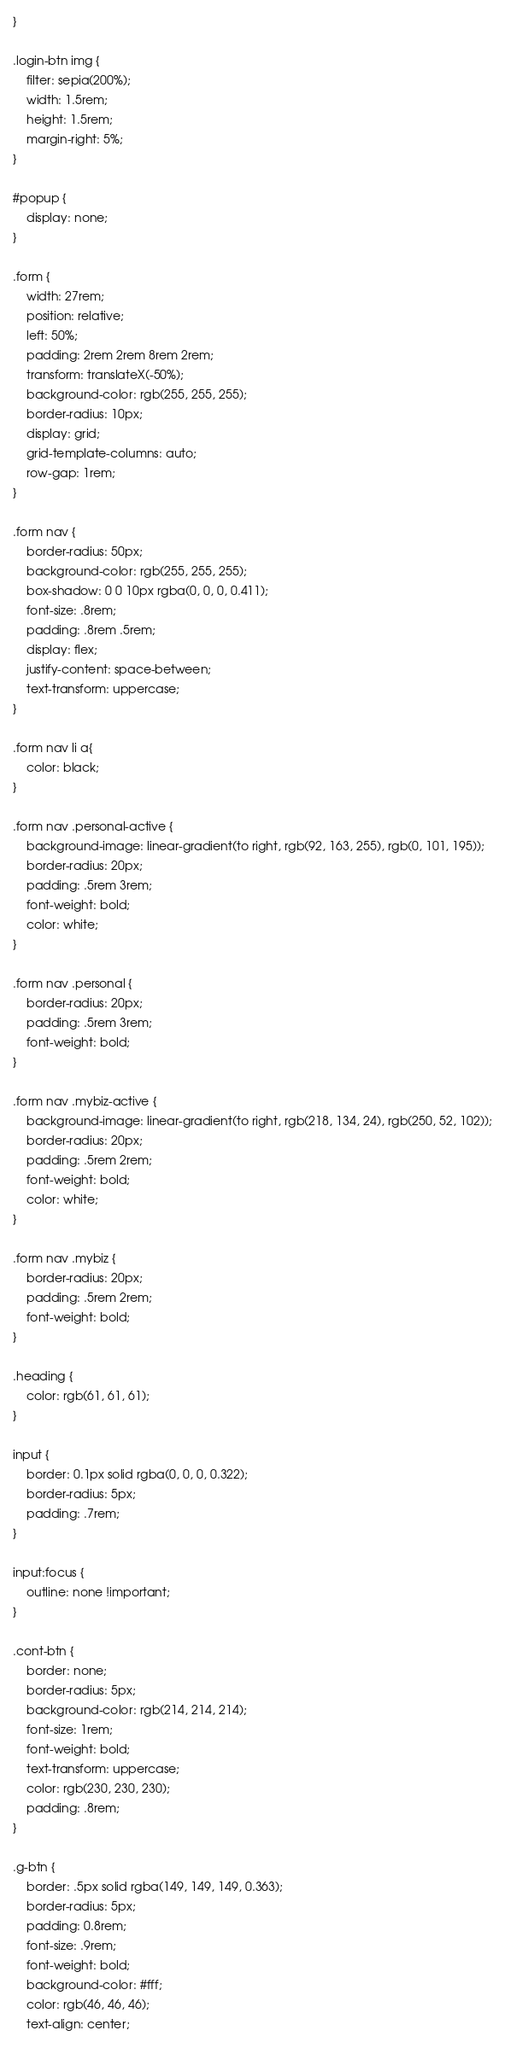Convert code to text. <code><loc_0><loc_0><loc_500><loc_500><_CSS_>}

.login-btn img {
    filter: sepia(200%);
    width: 1.5rem;
    height: 1.5rem;
    margin-right: 5%;
}

#popup {
    display: none;
}

.form {
    width: 27rem;
    position: relative;
    left: 50%;
    padding: 2rem 2rem 8rem 2rem;
    transform: translateX(-50%);
    background-color: rgb(255, 255, 255);
    border-radius: 10px;
    display: grid;
    grid-template-columns: auto;
    row-gap: 1rem;
}

.form nav {
    border-radius: 50px;
    background-color: rgb(255, 255, 255);
    box-shadow: 0 0 10px rgba(0, 0, 0, 0.411);
    font-size: .8rem;
    padding: .8rem .5rem;
    display: flex;
    justify-content: space-between;
    text-transform: uppercase;
}

.form nav li a{
    color: black;
}

.form nav .personal-active {
    background-image: linear-gradient(to right, rgb(92, 163, 255), rgb(0, 101, 195));
    border-radius: 20px;
    padding: .5rem 3rem;
    font-weight: bold;
    color: white;
}

.form nav .personal {
    border-radius: 20px;
    padding: .5rem 3rem;
    font-weight: bold;
}

.form nav .mybiz-active {
    background-image: linear-gradient(to right, rgb(218, 134, 24), rgb(250, 52, 102));
    border-radius: 20px;
    padding: .5rem 2rem;
    font-weight: bold;
    color: white;
}

.form nav .mybiz {
    border-radius: 20px;
    padding: .5rem 2rem;
    font-weight: bold;
}

.heading {
    color: rgb(61, 61, 61);
}

input {
    border: 0.1px solid rgba(0, 0, 0, 0.322);
    border-radius: 5px;
    padding: .7rem;
}

input:focus {
    outline: none !important;
}

.cont-btn {
    border: none;
    border-radius: 5px;
    background-color: rgb(214, 214, 214);
    font-size: 1rem;
    font-weight: bold;
    text-transform: uppercase;
    color: rgb(230, 230, 230);
    padding: .8rem;
}

.g-btn {
    border: .5px solid rgba(149, 149, 149, 0.363);
    border-radius: 5px;
    padding: 0.8rem;
    font-size: .9rem;
    font-weight: bold;
    background-color: #fff;
    color: rgb(46, 46, 46);
    text-align: center;</code> 